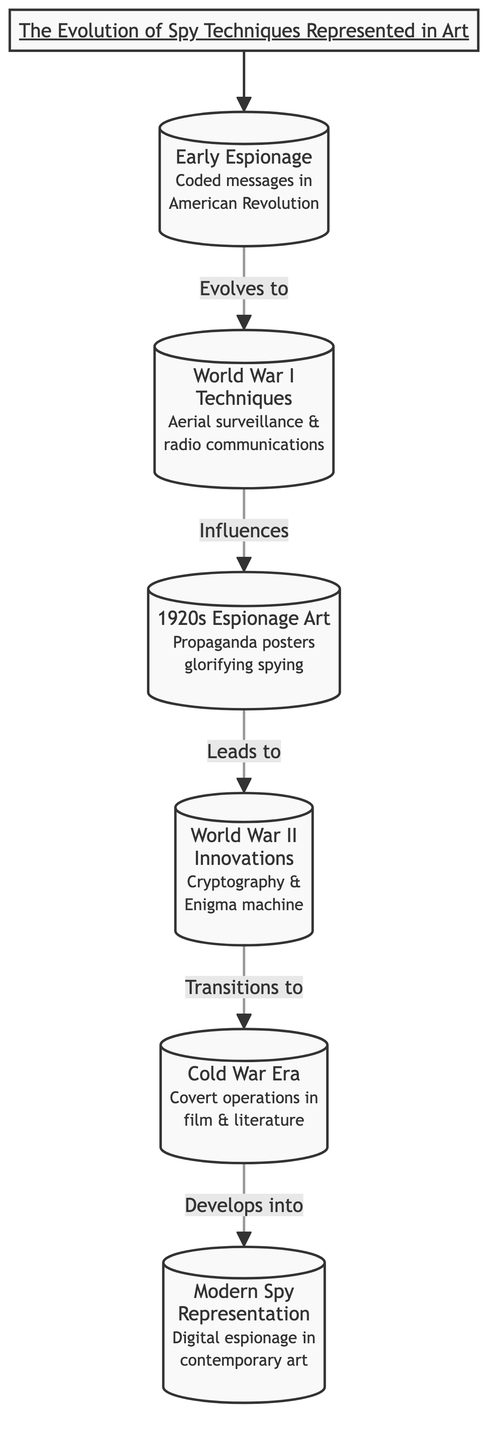What is the first node in the diagram? The first node in the diagram is "Early Espionage," which represents the historical use of coded messages during the American Revolutionary War.
Answer: Early Espionage How many nodes are present in the diagram? By counting each labeled element in the diagram, there are a total of six distinct nodes representing different stages of spy techniques.
Answer: 6 Which node directly follows the "World War I Techniques" node? Looking at the arrows indicating the flow, the node that directly follows "World War I Techniques" is "Espionage Art of the 1920s."
Answer: Espionage Art of the 1920s What type of art emerged in the 1920s related to espionage? The diagram specifies that propaganda posters glorifying spying emerged in the 1920s, indicating a cultural representation of espionage during that time.
Answer: Propaganda posters Which node is associated with the cryptography and Enigma machine? Following the connections in the diagram, the node detailing cryptography and the Enigma machine is "World War II Innovations."
Answer: World War II Innovations How do "World War II Innovations" and "Cold War Era" relate in the diagram? The diagram shows a direct transition from "World War II Innovations" to "Cold War Era," indicating that advancements during World War II influenced espionage techniques in the Cold War period.
Answer: Transition What is the last node in the sequence? The flow chart shows that the last node in the sequence is "Modern Spy Representation," which depicts digital espionage in contemporary art.
Answer: Modern Spy Representation Which nodes connect to illustrate the evolution of espionage techniques? The connections in the flow chart demonstrate that each node flows into the next, creating a sequence that starts with "Early Espionage" and ends with "Modern Spy Representation," illustrating the progression of espionage techniques in art.
Answer: By flow What does the "Cold War Era" node represent in terms of espionage representation? The diagram indicates that the "Cold War Era" node represents covert operations illustrated through film and literature, showcasing how espionage was culturally depicted during this time.
Answer: Covert operations through film and literature 